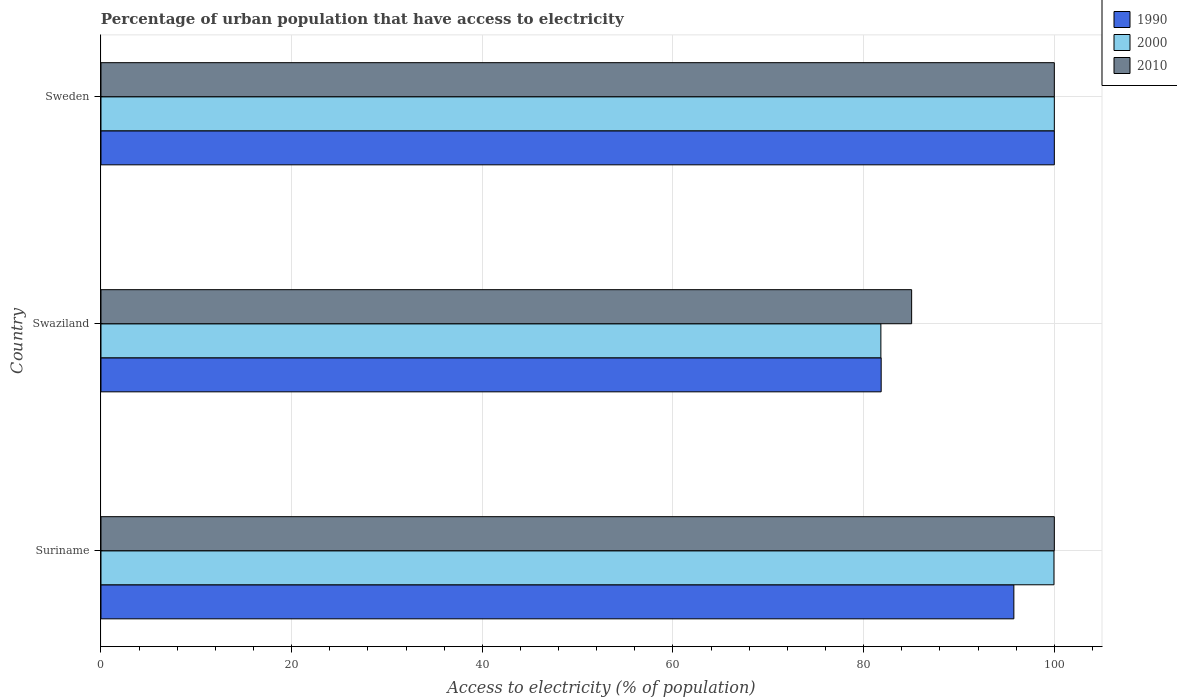How many groups of bars are there?
Your answer should be compact. 3. Are the number of bars per tick equal to the number of legend labels?
Keep it short and to the point. Yes. What is the label of the 3rd group of bars from the top?
Provide a short and direct response. Suriname. In how many cases, is the number of bars for a given country not equal to the number of legend labels?
Offer a very short reply. 0. What is the percentage of urban population that have access to electricity in 1990 in Swaziland?
Your response must be concise. 81.84. Across all countries, what is the minimum percentage of urban population that have access to electricity in 1990?
Offer a terse response. 81.84. In which country was the percentage of urban population that have access to electricity in 2000 maximum?
Give a very brief answer. Sweden. In which country was the percentage of urban population that have access to electricity in 2010 minimum?
Your response must be concise. Swaziland. What is the total percentage of urban population that have access to electricity in 1990 in the graph?
Ensure brevity in your answer.  277.59. What is the difference between the percentage of urban population that have access to electricity in 2010 in Suriname and that in Swaziland?
Provide a succinct answer. 14.97. What is the difference between the percentage of urban population that have access to electricity in 2010 in Sweden and the percentage of urban population that have access to electricity in 2000 in Swaziland?
Your response must be concise. 18.19. What is the average percentage of urban population that have access to electricity in 2000 per country?
Give a very brief answer. 93.92. What is the difference between the percentage of urban population that have access to electricity in 2000 and percentage of urban population that have access to electricity in 2010 in Suriname?
Your response must be concise. -0.04. What is the ratio of the percentage of urban population that have access to electricity in 2000 in Swaziland to that in Sweden?
Ensure brevity in your answer.  0.82. Is the percentage of urban population that have access to electricity in 1990 in Swaziland less than that in Sweden?
Provide a succinct answer. Yes. What is the difference between the highest and the second highest percentage of urban population that have access to electricity in 2000?
Provide a succinct answer. 0.04. What is the difference between the highest and the lowest percentage of urban population that have access to electricity in 2000?
Your answer should be compact. 18.19. Is the sum of the percentage of urban population that have access to electricity in 2000 in Suriname and Sweden greater than the maximum percentage of urban population that have access to electricity in 1990 across all countries?
Give a very brief answer. Yes. What does the 3rd bar from the bottom in Swaziland represents?
Offer a terse response. 2010. How many bars are there?
Offer a very short reply. 9. Are all the bars in the graph horizontal?
Provide a short and direct response. Yes. How many countries are there in the graph?
Provide a short and direct response. 3. Are the values on the major ticks of X-axis written in scientific E-notation?
Provide a short and direct response. No. Does the graph contain any zero values?
Your answer should be compact. No. Does the graph contain grids?
Keep it short and to the point. Yes. Where does the legend appear in the graph?
Keep it short and to the point. Top right. What is the title of the graph?
Offer a terse response. Percentage of urban population that have access to electricity. Does "1978" appear as one of the legend labels in the graph?
Keep it short and to the point. No. What is the label or title of the X-axis?
Ensure brevity in your answer.  Access to electricity (% of population). What is the Access to electricity (% of population) in 1990 in Suriname?
Give a very brief answer. 95.76. What is the Access to electricity (% of population) in 2000 in Suriname?
Ensure brevity in your answer.  99.96. What is the Access to electricity (% of population) of 2010 in Suriname?
Offer a very short reply. 100. What is the Access to electricity (% of population) in 1990 in Swaziland?
Your response must be concise. 81.84. What is the Access to electricity (% of population) of 2000 in Swaziland?
Offer a terse response. 81.81. What is the Access to electricity (% of population) of 2010 in Swaziland?
Your answer should be compact. 85.03. What is the Access to electricity (% of population) in 2010 in Sweden?
Provide a succinct answer. 100. Across all countries, what is the maximum Access to electricity (% of population) of 1990?
Offer a terse response. 100. Across all countries, what is the maximum Access to electricity (% of population) of 2000?
Give a very brief answer. 100. Across all countries, what is the minimum Access to electricity (% of population) in 1990?
Provide a short and direct response. 81.84. Across all countries, what is the minimum Access to electricity (% of population) in 2000?
Offer a terse response. 81.81. Across all countries, what is the minimum Access to electricity (% of population) in 2010?
Ensure brevity in your answer.  85.03. What is the total Access to electricity (% of population) in 1990 in the graph?
Your response must be concise. 277.59. What is the total Access to electricity (% of population) of 2000 in the graph?
Your answer should be compact. 281.77. What is the total Access to electricity (% of population) in 2010 in the graph?
Make the answer very short. 285.03. What is the difference between the Access to electricity (% of population) in 1990 in Suriname and that in Swaziland?
Make the answer very short. 13.92. What is the difference between the Access to electricity (% of population) of 2000 in Suriname and that in Swaziland?
Keep it short and to the point. 18.16. What is the difference between the Access to electricity (% of population) of 2010 in Suriname and that in Swaziland?
Offer a very short reply. 14.97. What is the difference between the Access to electricity (% of population) in 1990 in Suriname and that in Sweden?
Your response must be concise. -4.24. What is the difference between the Access to electricity (% of population) of 2000 in Suriname and that in Sweden?
Provide a short and direct response. -0.04. What is the difference between the Access to electricity (% of population) of 1990 in Swaziland and that in Sweden?
Offer a terse response. -18.16. What is the difference between the Access to electricity (% of population) of 2000 in Swaziland and that in Sweden?
Offer a terse response. -18.19. What is the difference between the Access to electricity (% of population) in 2010 in Swaziland and that in Sweden?
Your response must be concise. -14.97. What is the difference between the Access to electricity (% of population) in 1990 in Suriname and the Access to electricity (% of population) in 2000 in Swaziland?
Your response must be concise. 13.95. What is the difference between the Access to electricity (% of population) in 1990 in Suriname and the Access to electricity (% of population) in 2010 in Swaziland?
Offer a terse response. 10.72. What is the difference between the Access to electricity (% of population) of 2000 in Suriname and the Access to electricity (% of population) of 2010 in Swaziland?
Your answer should be compact. 14.93. What is the difference between the Access to electricity (% of population) in 1990 in Suriname and the Access to electricity (% of population) in 2000 in Sweden?
Provide a succinct answer. -4.24. What is the difference between the Access to electricity (% of population) in 1990 in Suriname and the Access to electricity (% of population) in 2010 in Sweden?
Your response must be concise. -4.24. What is the difference between the Access to electricity (% of population) in 2000 in Suriname and the Access to electricity (% of population) in 2010 in Sweden?
Give a very brief answer. -0.04. What is the difference between the Access to electricity (% of population) of 1990 in Swaziland and the Access to electricity (% of population) of 2000 in Sweden?
Offer a terse response. -18.16. What is the difference between the Access to electricity (% of population) in 1990 in Swaziland and the Access to electricity (% of population) in 2010 in Sweden?
Make the answer very short. -18.16. What is the difference between the Access to electricity (% of population) in 2000 in Swaziland and the Access to electricity (% of population) in 2010 in Sweden?
Your answer should be compact. -18.19. What is the average Access to electricity (% of population) of 1990 per country?
Your response must be concise. 92.53. What is the average Access to electricity (% of population) of 2000 per country?
Provide a short and direct response. 93.92. What is the average Access to electricity (% of population) in 2010 per country?
Make the answer very short. 95.01. What is the difference between the Access to electricity (% of population) in 1990 and Access to electricity (% of population) in 2000 in Suriname?
Provide a short and direct response. -4.21. What is the difference between the Access to electricity (% of population) of 1990 and Access to electricity (% of population) of 2010 in Suriname?
Give a very brief answer. -4.24. What is the difference between the Access to electricity (% of population) of 2000 and Access to electricity (% of population) of 2010 in Suriname?
Provide a short and direct response. -0.04. What is the difference between the Access to electricity (% of population) in 1990 and Access to electricity (% of population) in 2000 in Swaziland?
Ensure brevity in your answer.  0.03. What is the difference between the Access to electricity (% of population) in 1990 and Access to electricity (% of population) in 2010 in Swaziland?
Your answer should be very brief. -3.2. What is the difference between the Access to electricity (% of population) in 2000 and Access to electricity (% of population) in 2010 in Swaziland?
Ensure brevity in your answer.  -3.23. What is the difference between the Access to electricity (% of population) of 1990 and Access to electricity (% of population) of 2000 in Sweden?
Give a very brief answer. 0. What is the ratio of the Access to electricity (% of population) in 1990 in Suriname to that in Swaziland?
Make the answer very short. 1.17. What is the ratio of the Access to electricity (% of population) of 2000 in Suriname to that in Swaziland?
Offer a very short reply. 1.22. What is the ratio of the Access to electricity (% of population) in 2010 in Suriname to that in Swaziland?
Your answer should be compact. 1.18. What is the ratio of the Access to electricity (% of population) in 1990 in Suriname to that in Sweden?
Give a very brief answer. 0.96. What is the ratio of the Access to electricity (% of population) in 2000 in Suriname to that in Sweden?
Ensure brevity in your answer.  1. What is the ratio of the Access to electricity (% of population) of 2010 in Suriname to that in Sweden?
Your response must be concise. 1. What is the ratio of the Access to electricity (% of population) in 1990 in Swaziland to that in Sweden?
Offer a terse response. 0.82. What is the ratio of the Access to electricity (% of population) of 2000 in Swaziland to that in Sweden?
Make the answer very short. 0.82. What is the ratio of the Access to electricity (% of population) of 2010 in Swaziland to that in Sweden?
Offer a very short reply. 0.85. What is the difference between the highest and the second highest Access to electricity (% of population) of 1990?
Offer a very short reply. 4.24. What is the difference between the highest and the second highest Access to electricity (% of population) of 2000?
Provide a short and direct response. 0.04. What is the difference between the highest and the second highest Access to electricity (% of population) of 2010?
Offer a terse response. 0. What is the difference between the highest and the lowest Access to electricity (% of population) of 1990?
Your answer should be compact. 18.16. What is the difference between the highest and the lowest Access to electricity (% of population) in 2000?
Your answer should be compact. 18.19. What is the difference between the highest and the lowest Access to electricity (% of population) in 2010?
Offer a terse response. 14.97. 